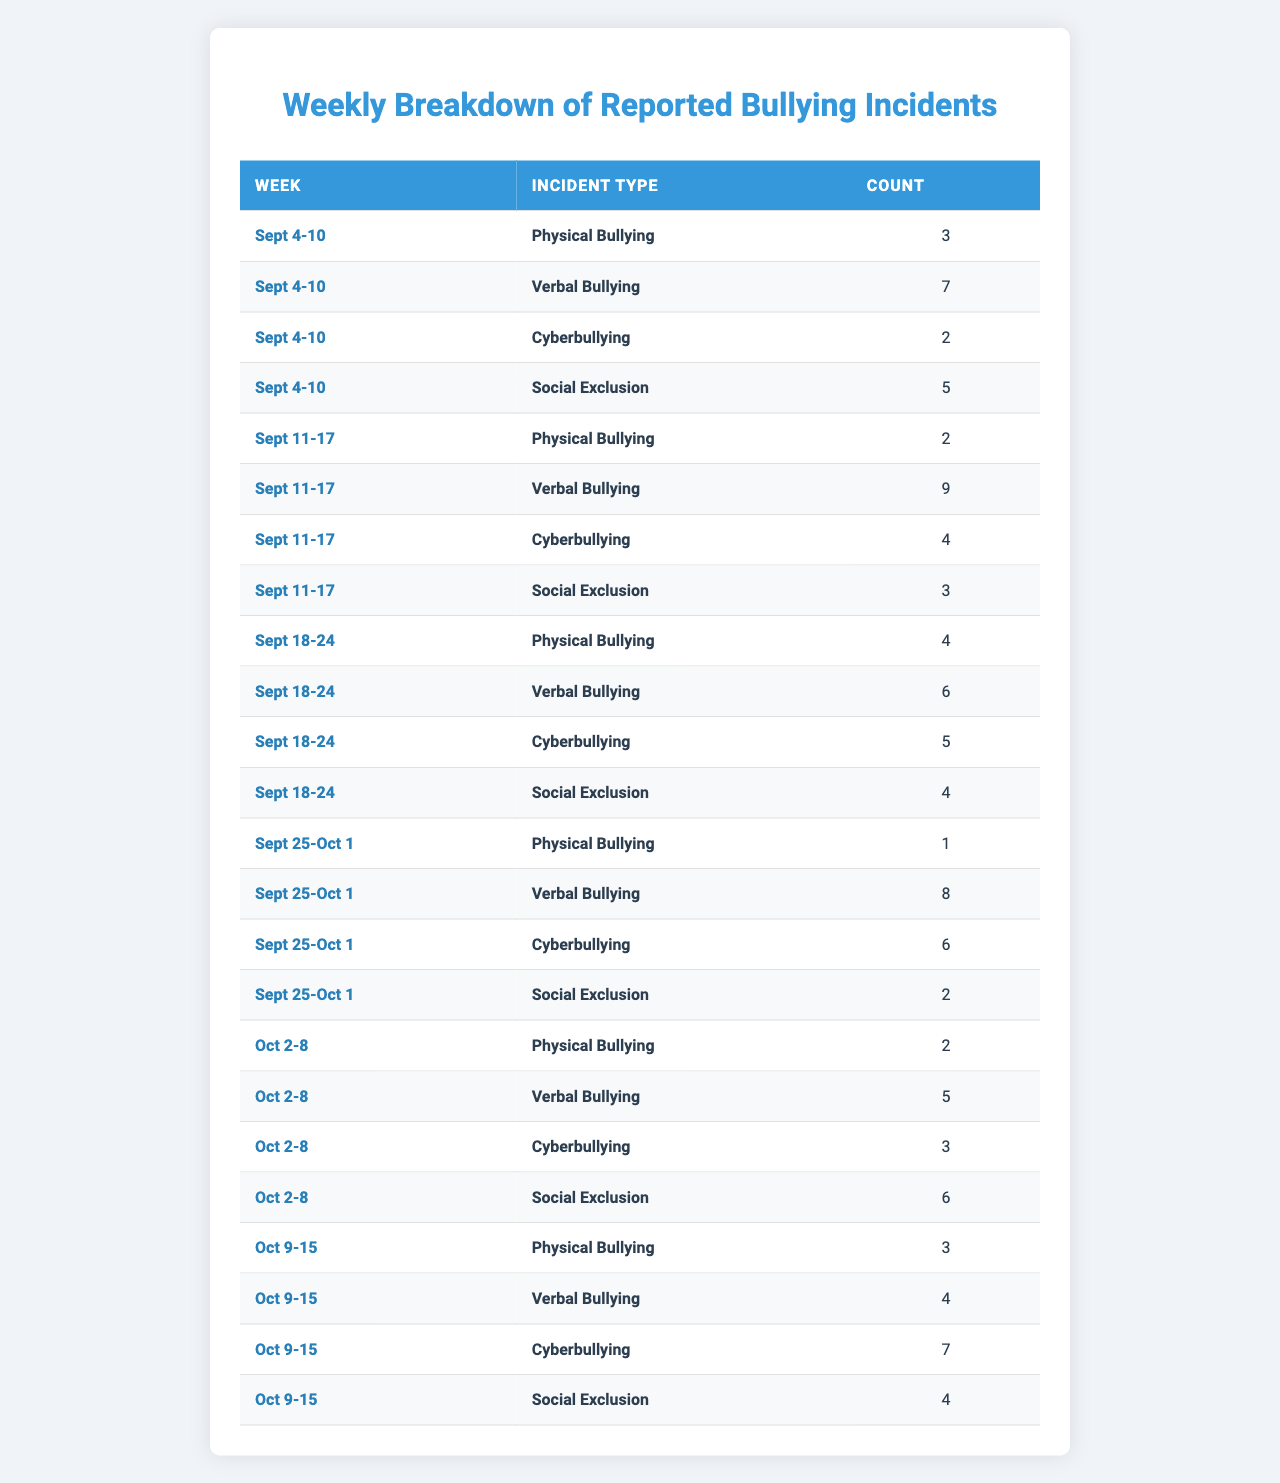What week had the highest number of Verbal Bullying incidents? Looking at the 'Verbal Bullying' column, the highest value is 9 incidents, which occurred during the week of Sept 11-17.
Answer: Sept 11-17 How many Cyberbullying incidents were reported in total from Sept 4-10 to Oct 9-15? By adding the Cyberbullying counts: 2 (Sept 4-10) + 4 (Sept 11-17) + 5 (Sept 18-24) + 6 (Sept 25-Oct 1) + 3 (Oct 2-8) + 7 (Oct 9-15) = 27.
Answer: 27 Is the number of Physical Bullying incidents higher in the week of Oct 2-8 compared to Sept 25-Oct 1? The Physical Bullying counts for Oct 2-8 is 2 while for Sept 25-Oct 1 it is 1, so 2 is greater than 1, indicating yes.
Answer: Yes What was the average number of Social Exclusion incidents reported across all weeks? To find the average, sum the Social Exclusion incidents: 5 + 3 + 4 + 2 + 6 + 4 = 24. Then divide by 6 weeks: 24 / 6 = 4.
Answer: 4 In which week did the total bullying incidents (all types combined) reach its peak? Adding all incidents for each week: Sept 4-10 = 17, Sept 11-17 = 19, Sept 18-24 = 19, Sept 25-Oct 1 = 17, Oct 2-8 = 16, Oct 9-15 = 18. The peak is 19 in the weeks of Sept 11-17 and Sept 18-24.
Answer: Sept 11-17 and Sept 18-24 How many weeks did the number of Physical Bullying incidents exceed 2? Looking through the Physical Bullying column, it exceeded 2 incidents in 3 weeks (Sept 4-10, Sept 18-24, and Oct 9-15).
Answer: 3 weeks Was there a week where Social Exclusion incidents were higher than Cyberbullying incidents? Comparing the counts, in the weeks of Sept 4-10 (5 vs. 2), Sept 11-17 (3 vs. 4), Sept 18-24 (4 vs. 5), Oct 2-8 (6 vs. 3), and Oct 9-15 (4 vs. 7): yes, in the week of Sept 4-10 and Oct 2-8.
Answer: Yes What is the difference in the number of Verbal Bullying incidents between the highest and lowest reporting weeks? The highest week (Sept 11-17) shows 9 incidents, and the lowest week (Oct 9-15) shows 4 incidents, so the difference is 9 - 4 = 5 incidents.
Answer: 5 incidents 